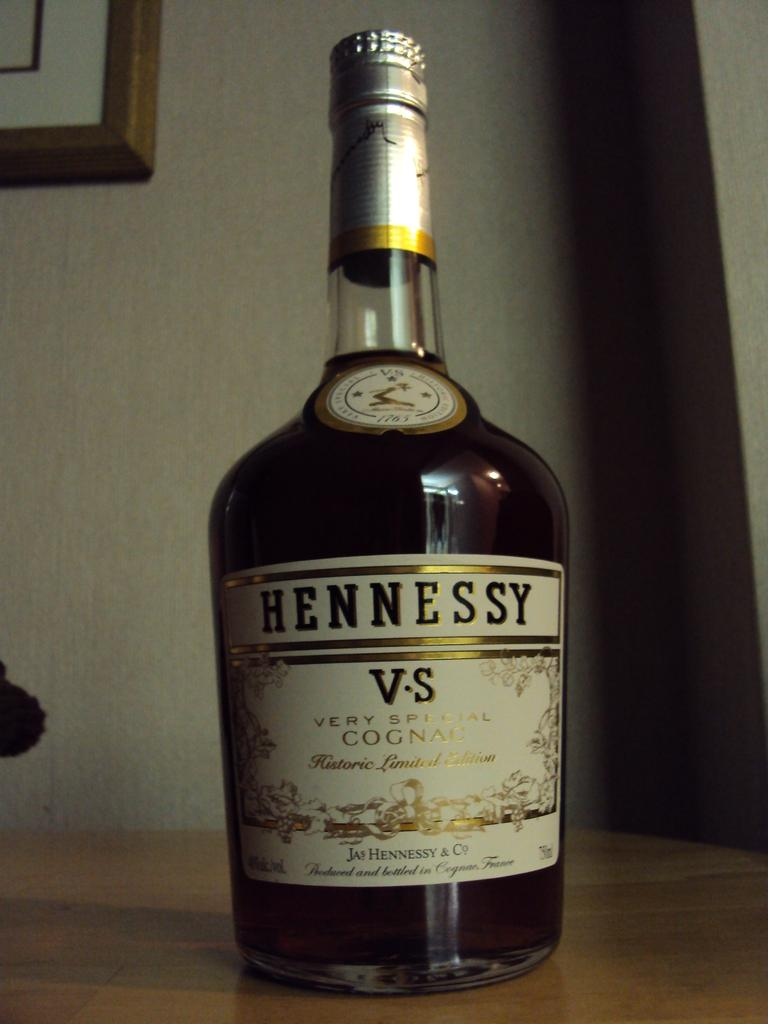<image>
Write a terse but informative summary of the picture. Large Hennessy bottle resting on a wooden table. 